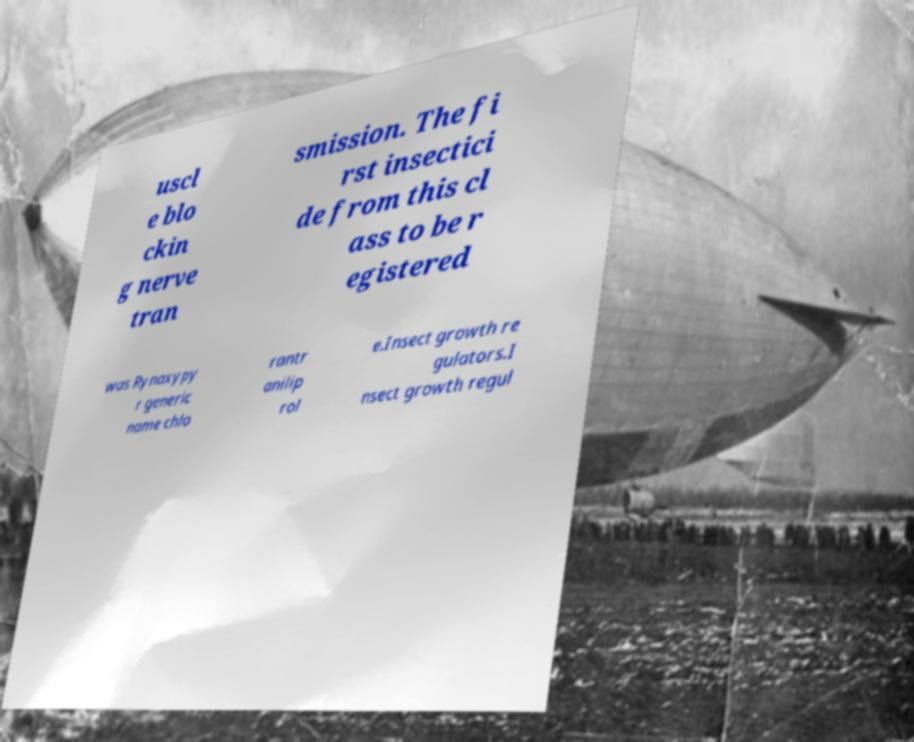Please identify and transcribe the text found in this image. uscl e blo ckin g nerve tran smission. The fi rst insectici de from this cl ass to be r egistered was Rynaxypy r generic name chlo rantr anilip rol e.Insect growth re gulators.I nsect growth regul 